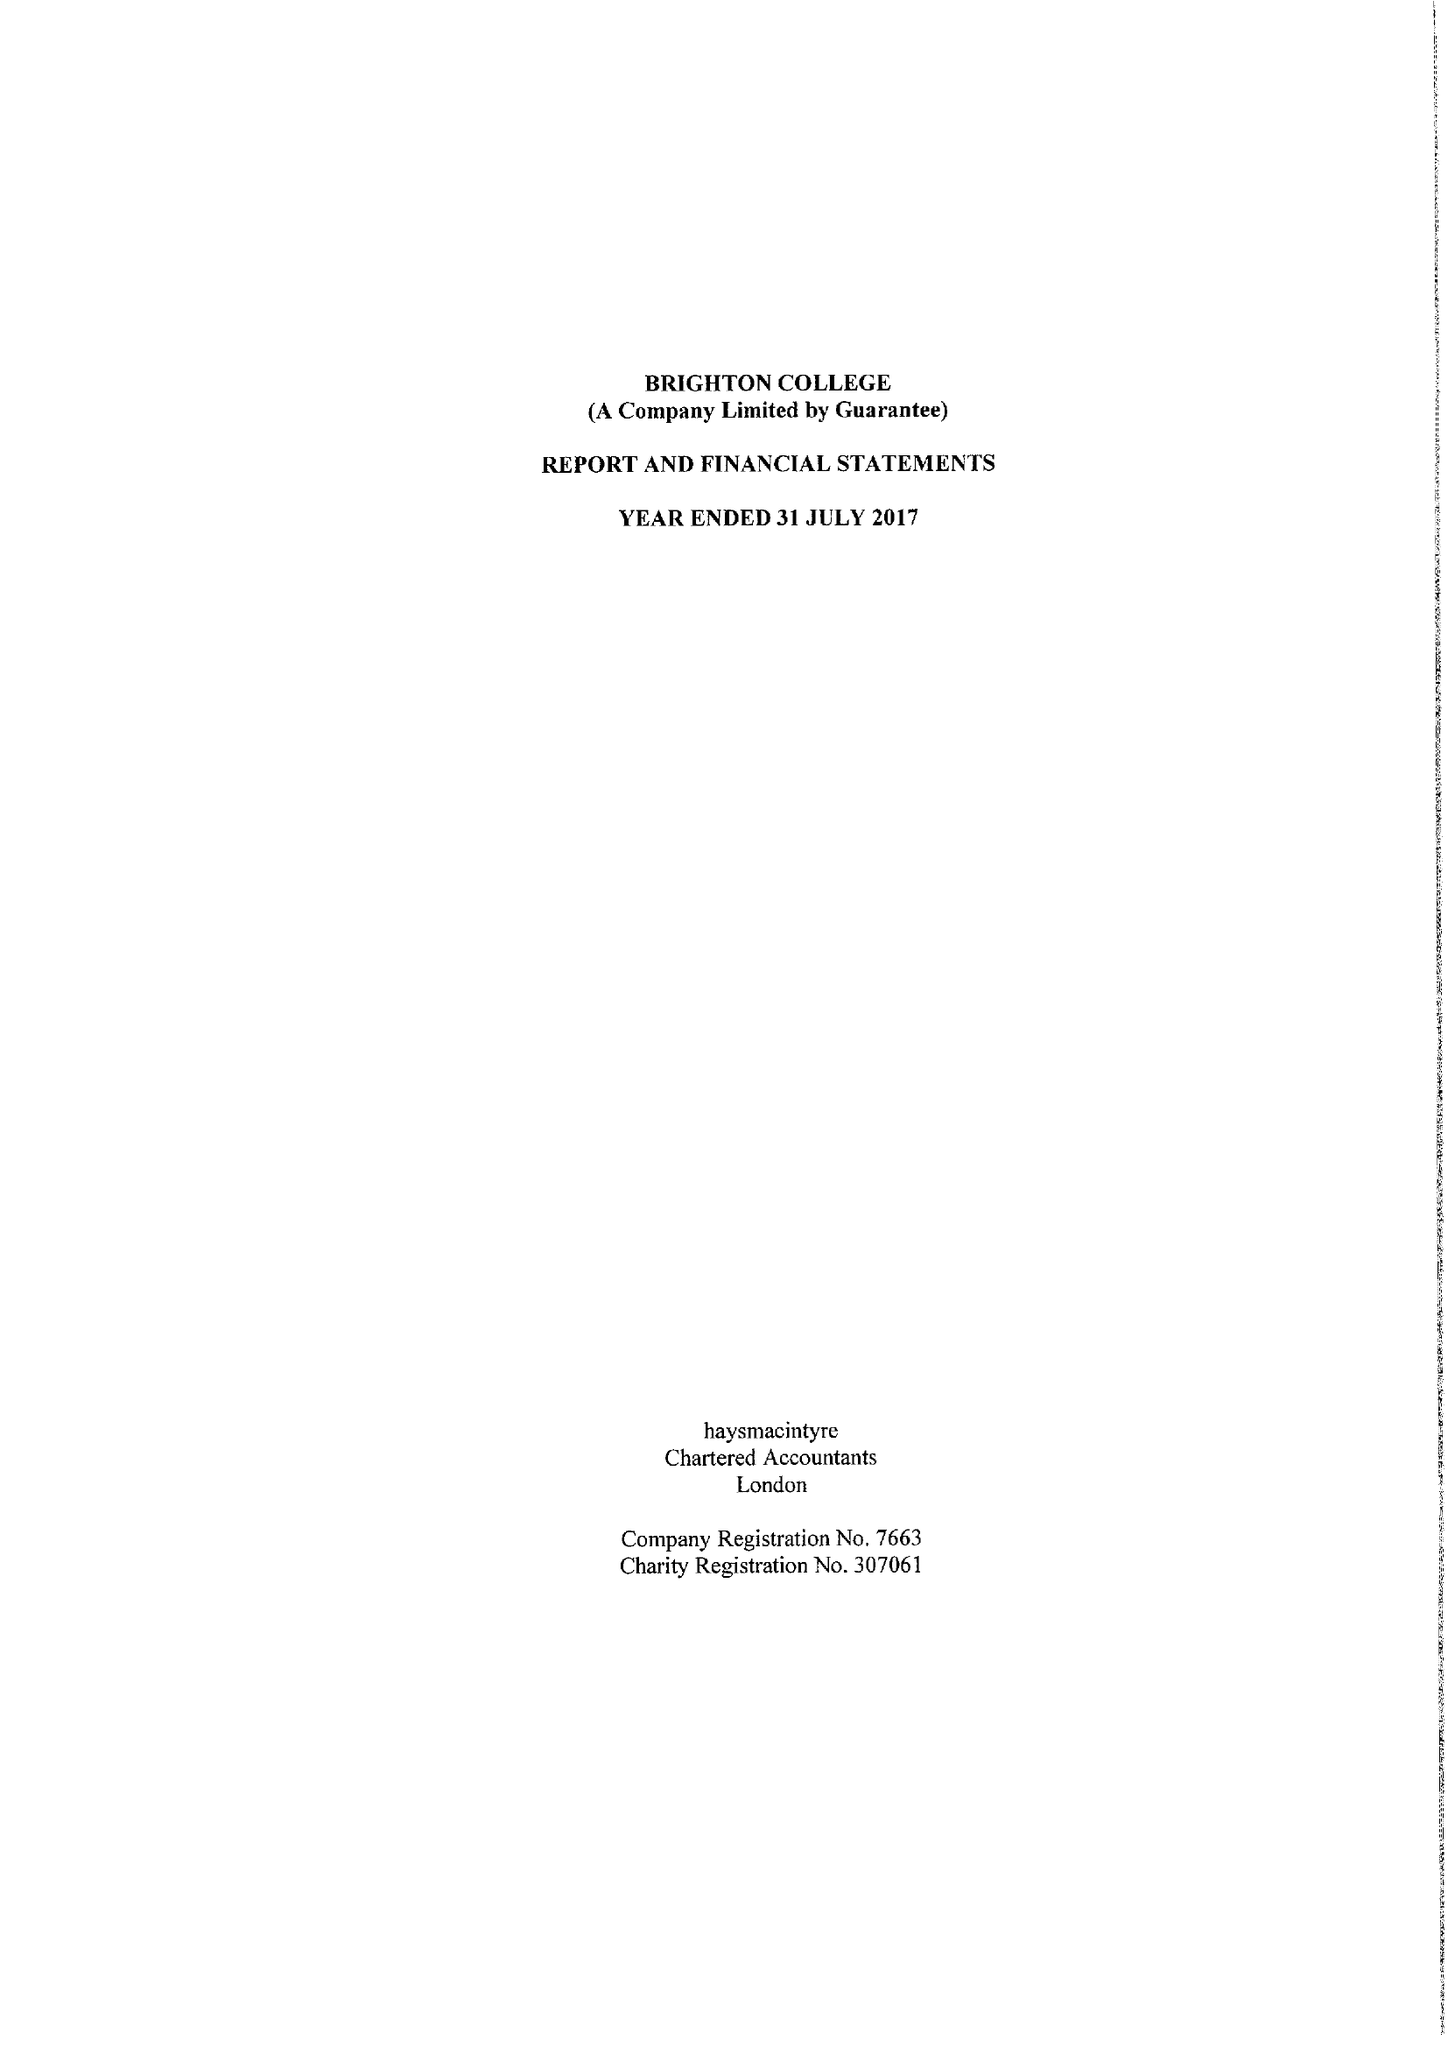What is the value for the address__postcode?
Answer the question using a single word or phrase. BN2 0AL 